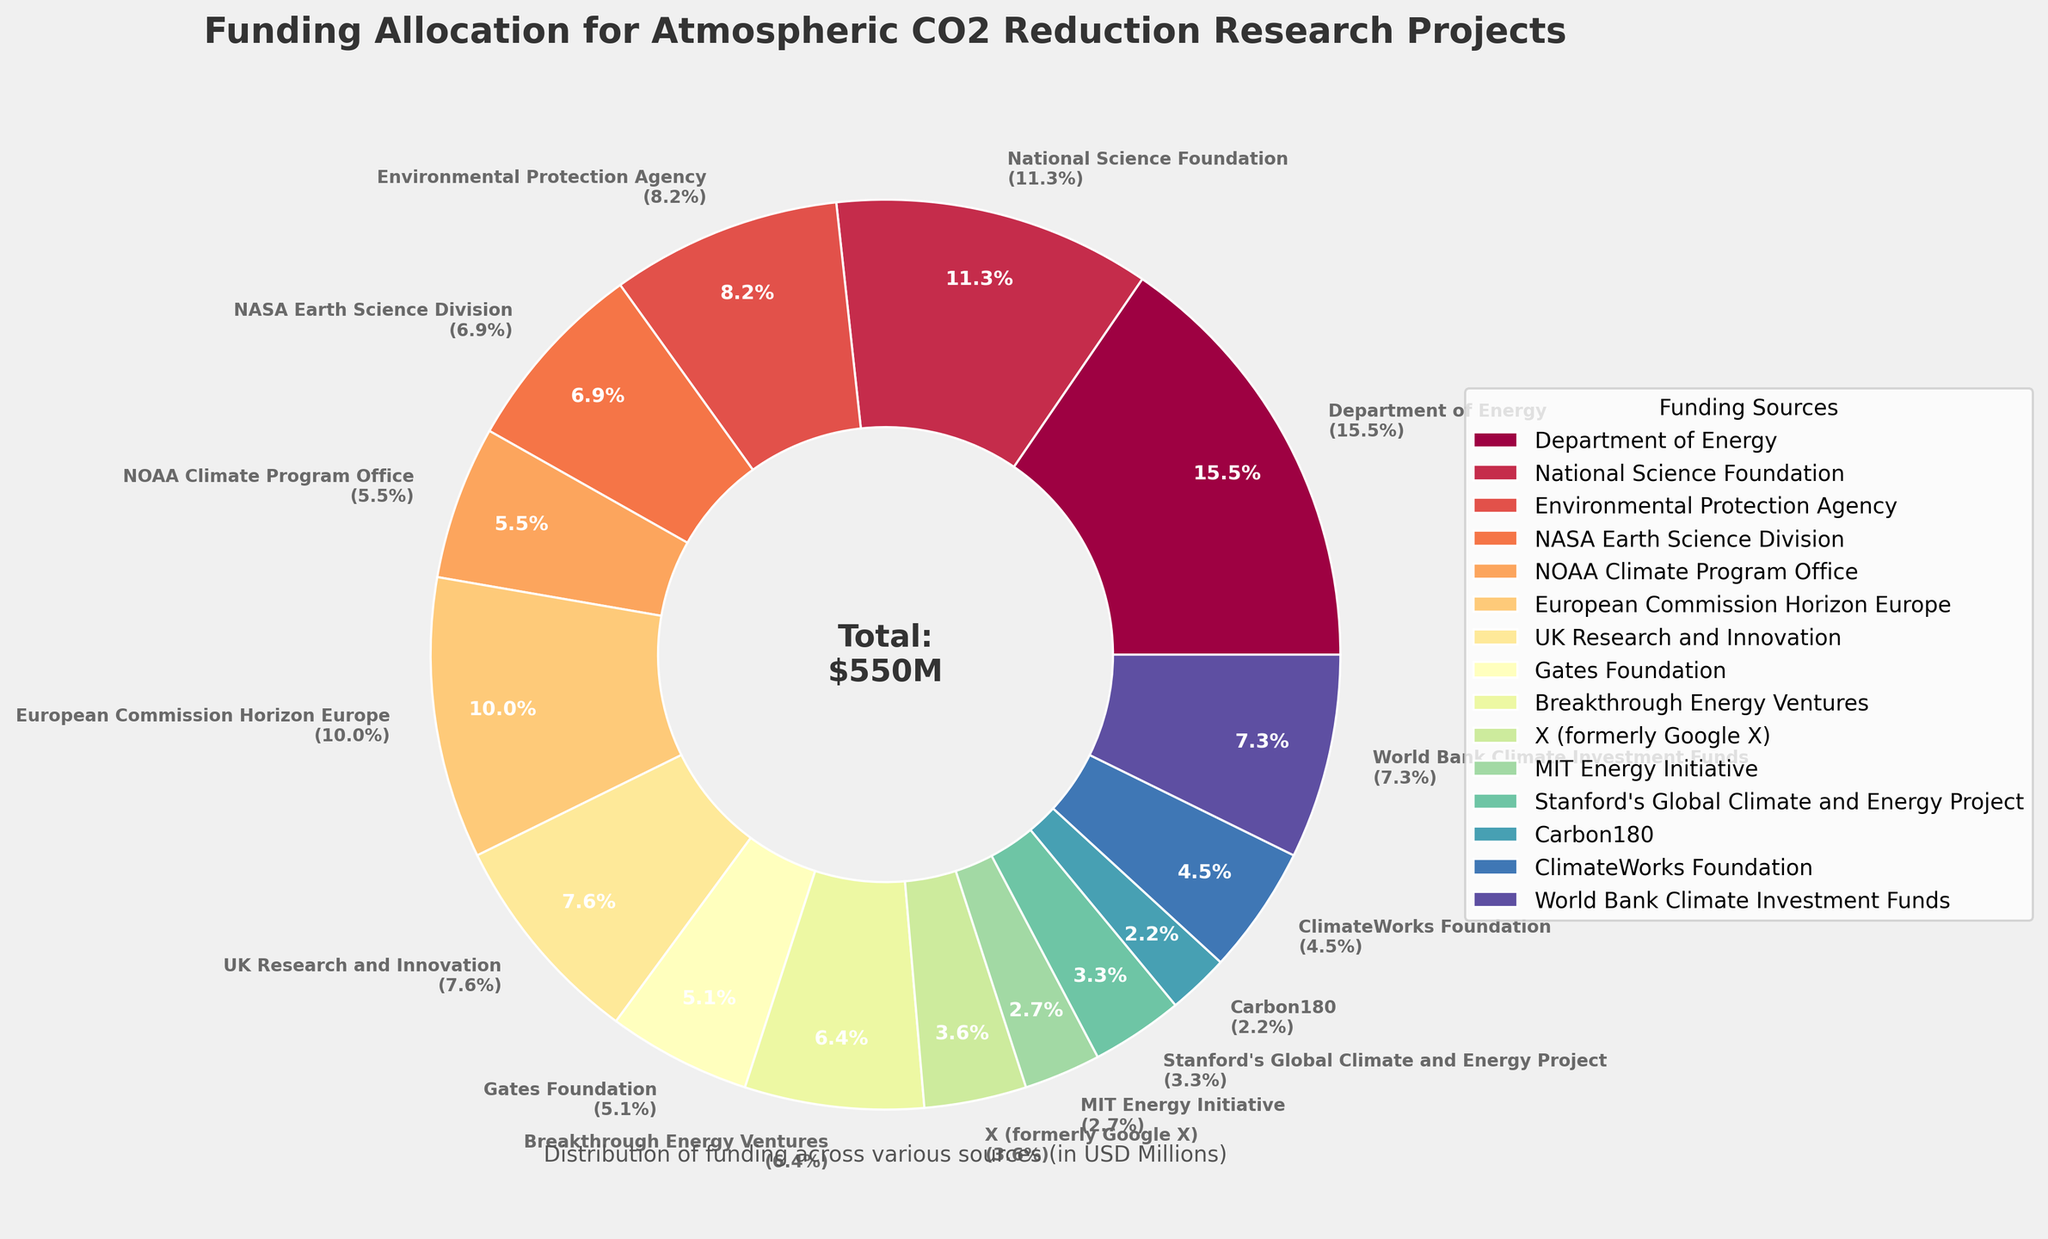What's the total funding allocated by the top three funding sources? Sum the funding from the top three sources: Department of Energy ($85M), National Science Foundation ($62M), and European Commission Horizon Europe ($55M). The total is 85 + 62 + 55 = $202M.
Answer: $202M Which funding source received the lowest allocation? The smallest slice in the pie chart corresponds to Carbon180 with $12M.
Answer: Carbon180 How much more funding does the Department of Energy receive compared to Breakthrough Energy Ventures? Subtract the funding of Breakthrough Energy Ventures ($35M) from the Department of Energy ($85M): 85 - 35 = $50M.
Answer: $50M What percentage of the total funding is provided by NASA Earth Science Division? The percentage is given in the label: 5.9%.
Answer: 5.9% Combine the funding from non-governmental organizations (Gates Foundation, Breakthrough Energy Ventures, and ClimateWorks Foundation). How much is it in total? Sum the funding from Gates Foundation ($28M), Breakthrough Energy Ventures ($35M), and ClimateWorks Foundation ($25M): 28 + 35 + 25 = $88M.
Answer: $88M Which organization received more funding: the Environmental Protection Agency or the World Bank Climate Investment Funds? Compare the funding: Environmental Protection Agency ($45M) vs. World Bank Climate Investment Funds ($40M). The Environmental Protection Agency received more.
Answer: Environmental Protection Agency How many funding sources received allocations of $30 million or greater? Count the slices with $30M or more: Department of Energy, National Science Foundation, Environmental Protection Agency, NASA Earth Science Division, European Commission Horizon Europe, UK Research and Innovation, NOAA Climate Program Office, and World Bank Climate Investment Funds. There are 8 such sources.
Answer: 8 What is the combined funding amount from UK and US organizations? Sum the funding from the following organizations: Department of Energy ($85M), National Science Foundation ($62M), Environmental Protection Agency ($45M), NASA Earth Science Division ($38M), NOAA Climate Program Office ($30M), MIT Energy Initiative ($15M), Stanford's Global Climate and Energy Project ($18M), Carbon180 ($12M), UK Research and Innovation ($42M). The total is 85 + 62 + 45 + 38 + 30 + 15 + 18 + 12 + 42 = $347M.
Answer: $347M Which funding source contributes approximately 5% of the total funding? The slice labeled 5.8% corresponds to the UK Research and Innovation.
Answer: UK Research and Innovation 